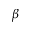<formula> <loc_0><loc_0><loc_500><loc_500>\beta</formula> 